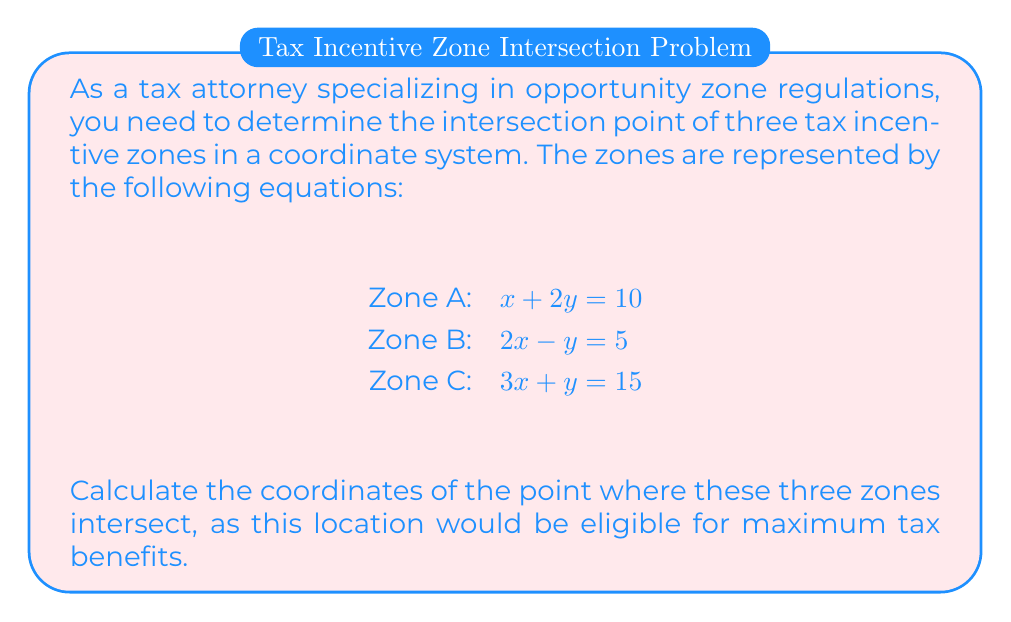Show me your answer to this math problem. To find the intersection point of the three tax incentive zones, we need to solve the system of equations:

1) $x + 2y = 10$
2) $2x - y = 5$
3) $3x + y = 15$

Step 1: Eliminate y using equations 2 and 3
Multiply equation 2 by 3 and equation 3 by 1:
$6x - 3y = 15$
$3x + y = 15$

Subtract the second equation from the first:
$3x - 4y = 0$
$y = \frac{3x}{4}$

Step 2: Substitute this expression for y into equation 1
$x + 2(\frac{3x}{4}) = 10$
$x + \frac{3x}{2} = 10$
$\frac{4x}{4} + \frac{6x}{4} = 10$
$\frac{10x}{4} = 10$
$10x = 40$
$x = 4$

Step 3: Calculate y using the value of x in any of the original equations
Using equation 1: $4 + 2y = 10$
$2y = 6$
$y = 3$

Step 4: Verify the solution satisfies all three equations
Zone A: $4 + 2(3) = 10$ (True)
Zone B: $2(4) - 3 = 5$ (True)
Zone C: $3(4) + 3 = 15$ (True)

Therefore, the intersection point of the three tax incentive zones is (4, 3).
Answer: (4, 3) 